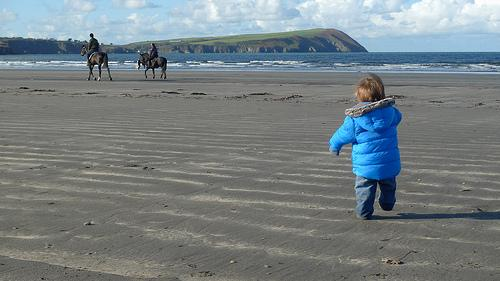Describe the scene in the image, focusing on the main subject and their surroundings. A small child wearing a blue jacket and jeans walks on a vast beach near two horse riders, with green hills, a cliff, and a lake forming the backdrop. Using descriptive words, explain the various elements present in the image. A tiny child, dressed in blue, meanders along the beach while majestic horse riders gallop close by amidst a magnificent landscape of hills, a cliff, and a sparkling lake. From a child's perspective, describe what the child can see and experience in the picture. There's a little kid in a blue coat on the beach, they can see horses, waves, hills and a big cliff, and the sand has tracks. Create a sentence reflecting the main components and actions within the image. Child in blue attire exploring a beach with nearby horse riders, set against a scenic background of lush hills, a cliffside, and an expansive lake. Capture the essence of the image focusing on the most important features. Child in a blue jacket walks on a beach with tracks in the sand, horse riders, green hills, cliffside and waves crashing. Provide a concise description of the main elements in the image. A small child in a blue jacket walks on the beach while two people ride horses, with a great lake, green hills, and a cliffside in the background. Write a brief summary of the main activities taking place in the image. Child strolling along the beach, alongside two horse riders, against the backdrop of a lake, hills, a cliff, and waves crashing ashore. Using vivid language, describe the main objects and the setting in the image. An endearing little child adorned in a blue outfit treads gently on the sandy beach, accompanied by horse riders, sweeping green hills, and the soothing sound of waves. From an artistic point of view, describe the visual elements and interesting aspects of the image. A vibrant image capturing a blue-clad child's beach walk, complemented by equestrian activity, a picturesque landscape featuring hills, a cliff, and a glistening lake. Clearly describing the image, mention the main objects and actions taking place. A child in a blue outfit walks on the beach, leaving tracks in the sand, as two people riding horses follow nearby, surrounded by a lake, hills, cliffs, and waves. 